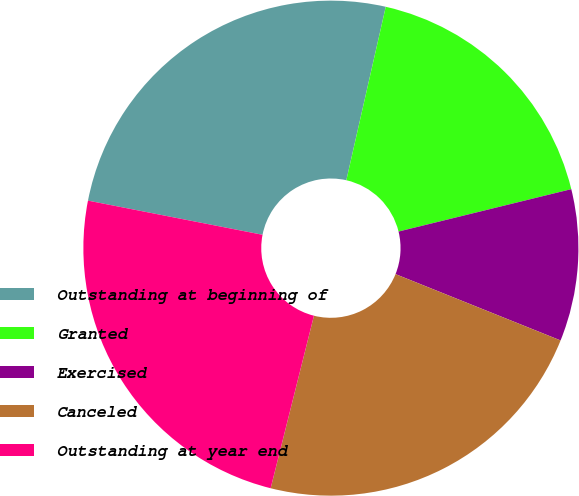Convert chart to OTSL. <chart><loc_0><loc_0><loc_500><loc_500><pie_chart><fcel>Outstanding at beginning of<fcel>Granted<fcel>Exercised<fcel>Canceled<fcel>Outstanding at year end<nl><fcel>25.48%<fcel>17.61%<fcel>9.91%<fcel>22.83%<fcel>24.16%<nl></chart> 